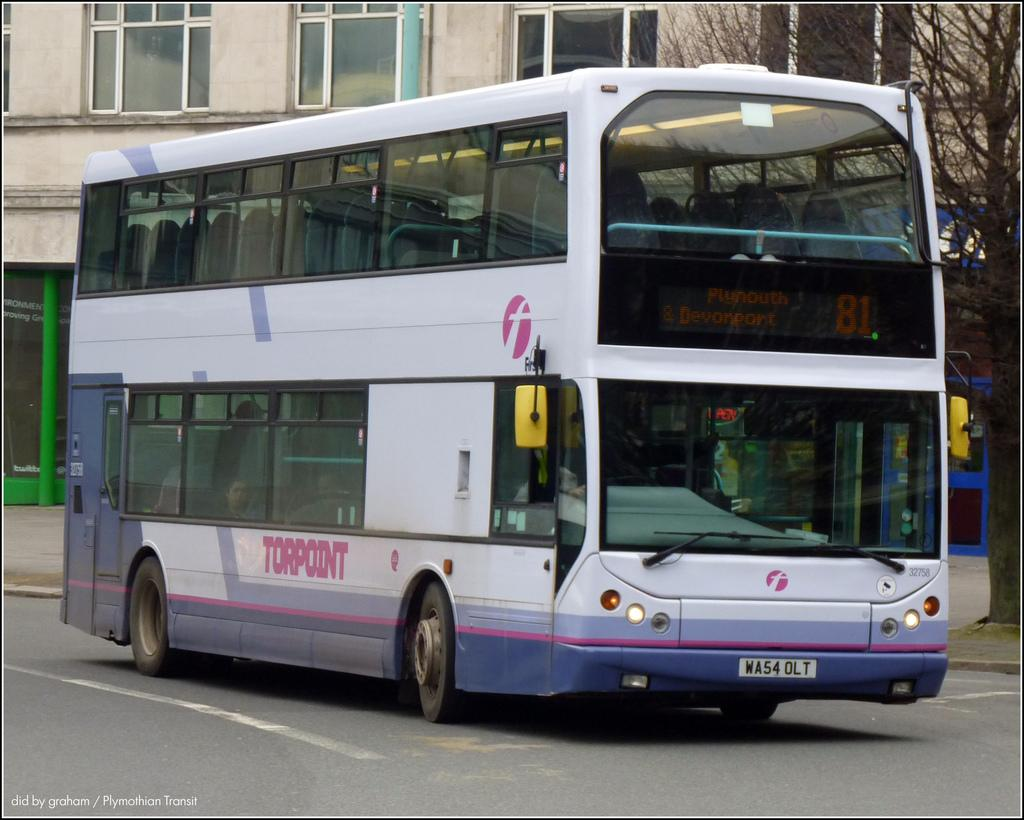What is the main subject of the image? There is a vehicle on the road in the image. What can be seen in the background of the image? There is a building and a tree in the background of the image. Is there any text visible in the image? Yes, there is some text visible in the bottom left corner of the image. What type of disease is affecting the yak in the image? There is no yak present in the image, so it is not possible to determine if a disease is affecting it. 